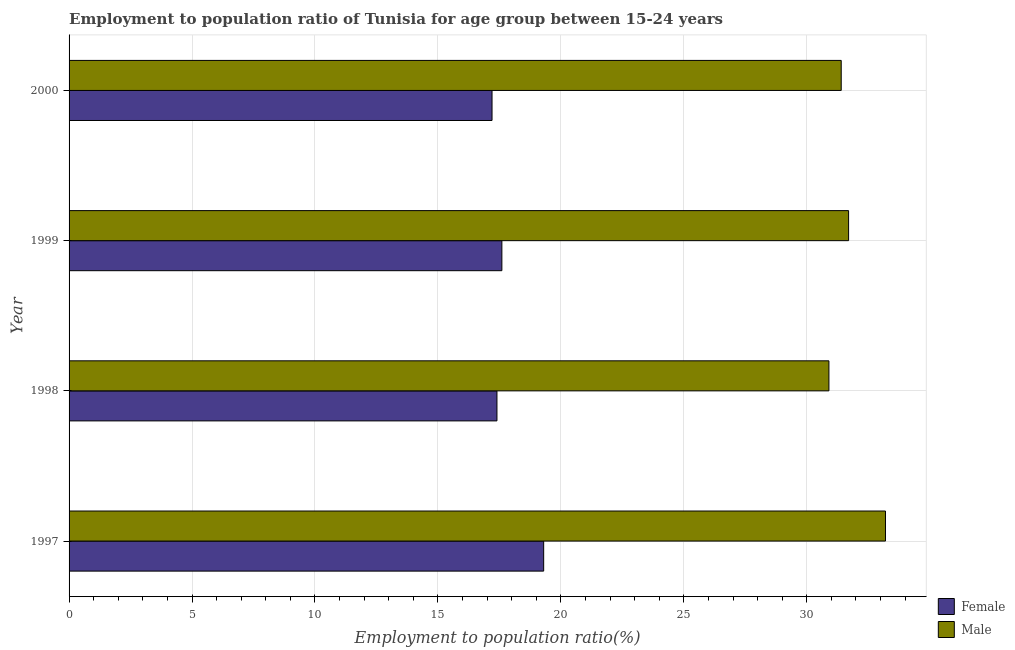Are the number of bars on each tick of the Y-axis equal?
Your response must be concise. Yes. How many bars are there on the 2nd tick from the top?
Offer a terse response. 2. How many bars are there on the 2nd tick from the bottom?
Your answer should be very brief. 2. What is the label of the 3rd group of bars from the top?
Keep it short and to the point. 1998. In how many cases, is the number of bars for a given year not equal to the number of legend labels?
Offer a terse response. 0. What is the employment to population ratio(female) in 1998?
Give a very brief answer. 17.4. Across all years, what is the maximum employment to population ratio(female)?
Provide a short and direct response. 19.3. Across all years, what is the minimum employment to population ratio(male)?
Make the answer very short. 30.9. In which year was the employment to population ratio(male) minimum?
Offer a very short reply. 1998. What is the total employment to population ratio(female) in the graph?
Offer a very short reply. 71.5. What is the difference between the employment to population ratio(male) in 2000 and the employment to population ratio(female) in 1999?
Your answer should be compact. 13.8. What is the average employment to population ratio(male) per year?
Offer a terse response. 31.8. In the year 1998, what is the difference between the employment to population ratio(female) and employment to population ratio(male)?
Your answer should be compact. -13.5. What is the ratio of the employment to population ratio(female) in 1997 to that in 1999?
Your response must be concise. 1.1. Is the employment to population ratio(male) in 1998 less than that in 2000?
Offer a very short reply. Yes. What is the difference between the highest and the second highest employment to population ratio(female)?
Provide a succinct answer. 1.7. What is the difference between the highest and the lowest employment to population ratio(female)?
Provide a short and direct response. 2.1. In how many years, is the employment to population ratio(female) greater than the average employment to population ratio(female) taken over all years?
Give a very brief answer. 1. Is the sum of the employment to population ratio(female) in 1997 and 1998 greater than the maximum employment to population ratio(male) across all years?
Give a very brief answer. Yes. What does the 1st bar from the top in 1999 represents?
Offer a very short reply. Male. How many years are there in the graph?
Provide a succinct answer. 4. What is the difference between two consecutive major ticks on the X-axis?
Give a very brief answer. 5. Are the values on the major ticks of X-axis written in scientific E-notation?
Your answer should be compact. No. Does the graph contain grids?
Provide a succinct answer. Yes. How many legend labels are there?
Provide a short and direct response. 2. How are the legend labels stacked?
Ensure brevity in your answer.  Vertical. What is the title of the graph?
Your response must be concise. Employment to population ratio of Tunisia for age group between 15-24 years. What is the label or title of the X-axis?
Keep it short and to the point. Employment to population ratio(%). What is the label or title of the Y-axis?
Provide a succinct answer. Year. What is the Employment to population ratio(%) of Female in 1997?
Your answer should be compact. 19.3. What is the Employment to population ratio(%) of Male in 1997?
Provide a succinct answer. 33.2. What is the Employment to population ratio(%) in Female in 1998?
Provide a short and direct response. 17.4. What is the Employment to population ratio(%) in Male in 1998?
Give a very brief answer. 30.9. What is the Employment to population ratio(%) of Female in 1999?
Provide a short and direct response. 17.6. What is the Employment to population ratio(%) in Male in 1999?
Give a very brief answer. 31.7. What is the Employment to population ratio(%) in Female in 2000?
Offer a very short reply. 17.2. What is the Employment to population ratio(%) in Male in 2000?
Provide a short and direct response. 31.4. Across all years, what is the maximum Employment to population ratio(%) in Female?
Your response must be concise. 19.3. Across all years, what is the maximum Employment to population ratio(%) in Male?
Provide a succinct answer. 33.2. Across all years, what is the minimum Employment to population ratio(%) of Female?
Your answer should be very brief. 17.2. Across all years, what is the minimum Employment to population ratio(%) in Male?
Provide a succinct answer. 30.9. What is the total Employment to population ratio(%) in Female in the graph?
Make the answer very short. 71.5. What is the total Employment to population ratio(%) of Male in the graph?
Offer a terse response. 127.2. What is the difference between the Employment to population ratio(%) in Female in 1997 and that in 1998?
Offer a terse response. 1.9. What is the difference between the Employment to population ratio(%) in Male in 1997 and that in 1999?
Offer a terse response. 1.5. What is the difference between the Employment to population ratio(%) of Female in 1997 and that in 2000?
Make the answer very short. 2.1. What is the difference between the Employment to population ratio(%) in Male in 1997 and that in 2000?
Provide a short and direct response. 1.8. What is the difference between the Employment to population ratio(%) of Female in 1998 and that in 1999?
Offer a terse response. -0.2. What is the difference between the Employment to population ratio(%) of Male in 1998 and that in 1999?
Your response must be concise. -0.8. What is the difference between the Employment to population ratio(%) of Female in 1998 and that in 2000?
Offer a very short reply. 0.2. What is the difference between the Employment to population ratio(%) in Male in 1998 and that in 2000?
Your answer should be compact. -0.5. What is the difference between the Employment to population ratio(%) of Male in 1999 and that in 2000?
Provide a short and direct response. 0.3. What is the difference between the Employment to population ratio(%) in Female in 1998 and the Employment to population ratio(%) in Male in 1999?
Provide a succinct answer. -14.3. What is the difference between the Employment to population ratio(%) in Female in 1998 and the Employment to population ratio(%) in Male in 2000?
Make the answer very short. -14. What is the average Employment to population ratio(%) of Female per year?
Provide a succinct answer. 17.88. What is the average Employment to population ratio(%) in Male per year?
Give a very brief answer. 31.8. In the year 1999, what is the difference between the Employment to population ratio(%) in Female and Employment to population ratio(%) in Male?
Provide a short and direct response. -14.1. What is the ratio of the Employment to population ratio(%) of Female in 1997 to that in 1998?
Offer a terse response. 1.11. What is the ratio of the Employment to population ratio(%) of Male in 1997 to that in 1998?
Ensure brevity in your answer.  1.07. What is the ratio of the Employment to population ratio(%) of Female in 1997 to that in 1999?
Ensure brevity in your answer.  1.1. What is the ratio of the Employment to population ratio(%) of Male in 1997 to that in 1999?
Offer a terse response. 1.05. What is the ratio of the Employment to population ratio(%) in Female in 1997 to that in 2000?
Ensure brevity in your answer.  1.12. What is the ratio of the Employment to population ratio(%) in Male in 1997 to that in 2000?
Provide a short and direct response. 1.06. What is the ratio of the Employment to population ratio(%) in Male in 1998 to that in 1999?
Offer a terse response. 0.97. What is the ratio of the Employment to population ratio(%) of Female in 1998 to that in 2000?
Keep it short and to the point. 1.01. What is the ratio of the Employment to population ratio(%) of Male in 1998 to that in 2000?
Ensure brevity in your answer.  0.98. What is the ratio of the Employment to population ratio(%) in Female in 1999 to that in 2000?
Your answer should be compact. 1.02. What is the ratio of the Employment to population ratio(%) in Male in 1999 to that in 2000?
Offer a terse response. 1.01. What is the difference between the highest and the second highest Employment to population ratio(%) in Female?
Offer a terse response. 1.7. What is the difference between the highest and the lowest Employment to population ratio(%) in Female?
Provide a short and direct response. 2.1. What is the difference between the highest and the lowest Employment to population ratio(%) in Male?
Give a very brief answer. 2.3. 